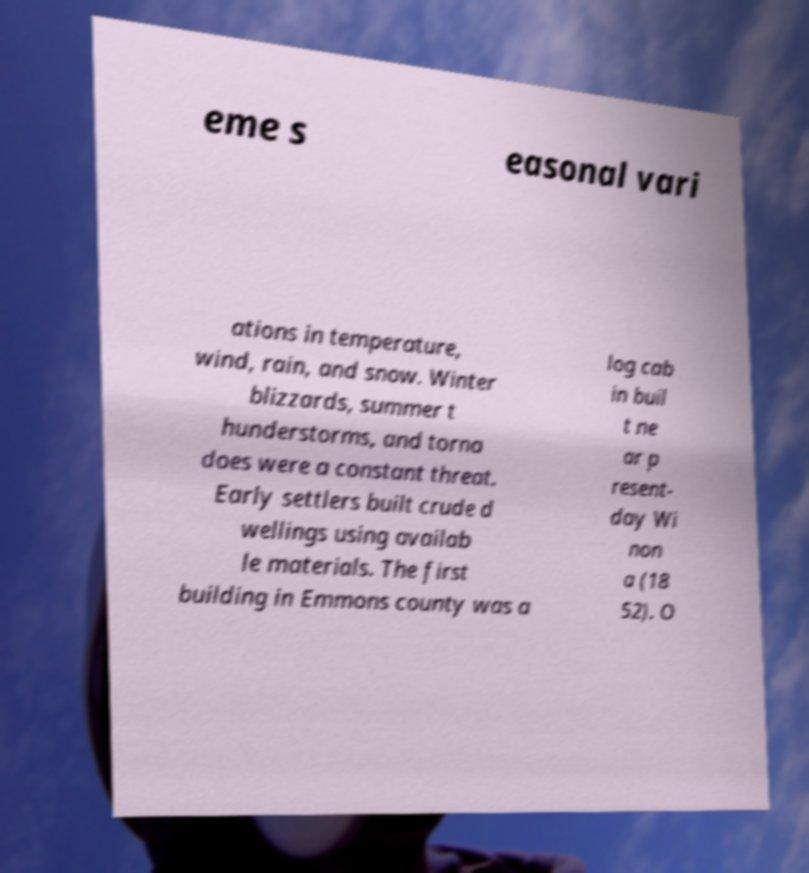What messages or text are displayed in this image? I need them in a readable, typed format. eme s easonal vari ations in temperature, wind, rain, and snow. Winter blizzards, summer t hunderstorms, and torna does were a constant threat. Early settlers built crude d wellings using availab le materials. The first building in Emmons county was a log cab in buil t ne ar p resent- day Wi non a (18 52). O 